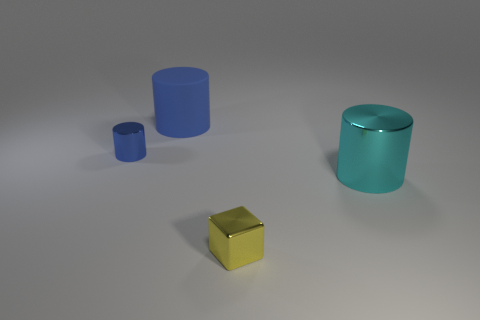Add 2 small yellow cubes. How many objects exist? 6 Subtract all cylinders. How many objects are left? 1 Add 3 tiny yellow metal cubes. How many tiny yellow metal cubes exist? 4 Subtract 1 cyan cylinders. How many objects are left? 3 Subtract all large red rubber cubes. Subtract all small yellow metal cubes. How many objects are left? 3 Add 2 large cyan metallic objects. How many large cyan metallic objects are left? 3 